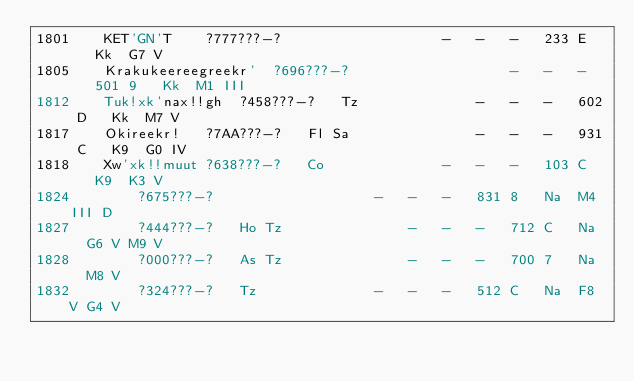<code> <loc_0><loc_0><loc_500><loc_500><_SQL_>1801	KET'GN'T	?777???-?	 				-	-	-	233	E	Kk	G7 V
1805	Krakukeereegreekr'	?696???-?					-	-	-	501	9	Kk	M1 III
1812	Tuk!xk'nax!!gh	?458???-?	Tz				-	-	-	602	D	Kk	M7 V
1817	Okireekr!	?7AA???-?	Fl Sa				-	-	-	931	C	K9	G0 IV
1818	Xw'xk!!muut	?638???-?	Co 				-	-	-	103	C	K9	K3 V
1824		?675???-?					-	-	-	831	8	Na	M4 III D
1827		?444???-?	Ho Tz				-	-	-	712	C	Na	G6 V M9 V
1828		?000???-?	As Tz				-	-	-	700	7	Na	M8 V
1832		?324???-?	Tz				-	-	-	512	C	Na	F8 V G4 V</code> 